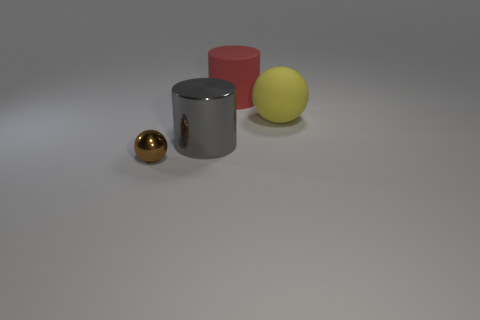Do the ball that is in front of the rubber sphere and the big yellow matte sphere have the same size?
Give a very brief answer. No. How many other things are the same color as the big metallic cylinder?
Ensure brevity in your answer.  0. How many yellow spheres have the same material as the brown sphere?
Make the answer very short. 0. There is a cylinder right of the gray thing; is its color the same as the metal cylinder?
Offer a very short reply. No. How many gray objects are large cylinders or shiny balls?
Your answer should be very brief. 1. Are there any other things that have the same material as the gray cylinder?
Your response must be concise. Yes. Are the sphere right of the tiny brown metallic object and the red thing made of the same material?
Offer a very short reply. Yes. What number of things are either large metal objects or balls to the right of the red cylinder?
Make the answer very short. 2. There is a metallic thing that is left of the shiny thing behind the small brown metallic sphere; how many large gray cylinders are on the left side of it?
Give a very brief answer. 0. There is a rubber object that is in front of the big red cylinder; is it the same shape as the tiny brown object?
Your answer should be compact. Yes. 